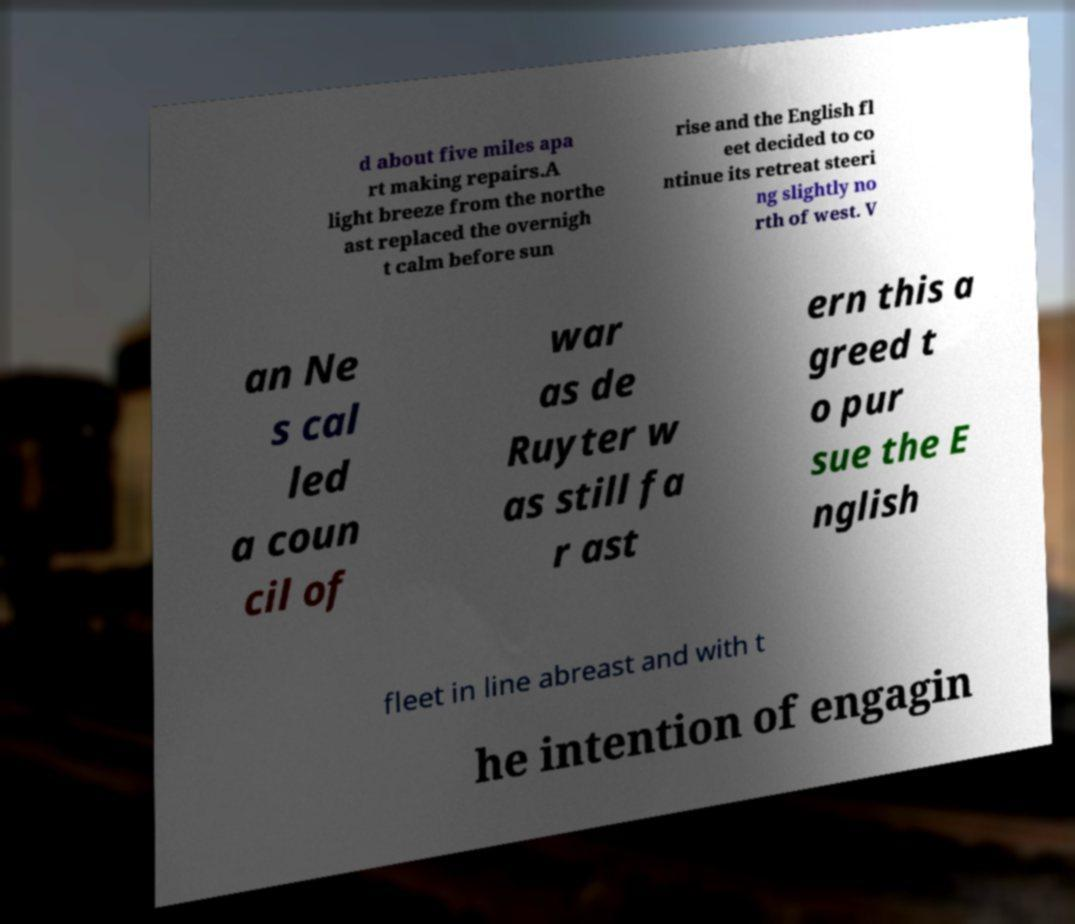Could you assist in decoding the text presented in this image and type it out clearly? d about five miles apa rt making repairs.A light breeze from the northe ast replaced the overnigh t calm before sun rise and the English fl eet decided to co ntinue its retreat steeri ng slightly no rth of west. V an Ne s cal led a coun cil of war as de Ruyter w as still fa r ast ern this a greed t o pur sue the E nglish fleet in line abreast and with t he intention of engagin 